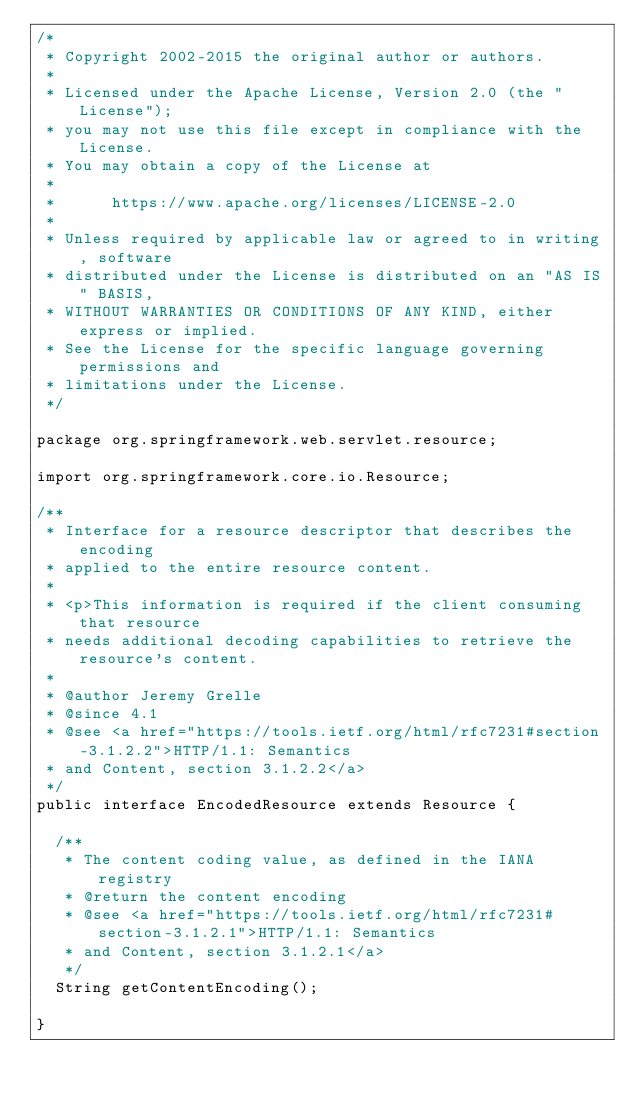Convert code to text. <code><loc_0><loc_0><loc_500><loc_500><_Java_>/*
 * Copyright 2002-2015 the original author or authors.
 *
 * Licensed under the Apache License, Version 2.0 (the "License");
 * you may not use this file except in compliance with the License.
 * You may obtain a copy of the License at
 *
 *      https://www.apache.org/licenses/LICENSE-2.0
 *
 * Unless required by applicable law or agreed to in writing, software
 * distributed under the License is distributed on an "AS IS" BASIS,
 * WITHOUT WARRANTIES OR CONDITIONS OF ANY KIND, either express or implied.
 * See the License for the specific language governing permissions and
 * limitations under the License.
 */

package org.springframework.web.servlet.resource;

import org.springframework.core.io.Resource;

/**
 * Interface for a resource descriptor that describes the encoding
 * applied to the entire resource content.
 *
 * <p>This information is required if the client consuming that resource
 * needs additional decoding capabilities to retrieve the resource's content.
 *
 * @author Jeremy Grelle
 * @since 4.1
 * @see <a href="https://tools.ietf.org/html/rfc7231#section-3.1.2.2">HTTP/1.1: Semantics
 * and Content, section 3.1.2.2</a>
 */
public interface EncodedResource extends Resource {

	/**
	 * The content coding value, as defined in the IANA registry
	 * @return the content encoding
	 * @see <a href="https://tools.ietf.org/html/rfc7231#section-3.1.2.1">HTTP/1.1: Semantics
	 * and Content, section 3.1.2.1</a>
	 */
	String getContentEncoding();

}
</code> 